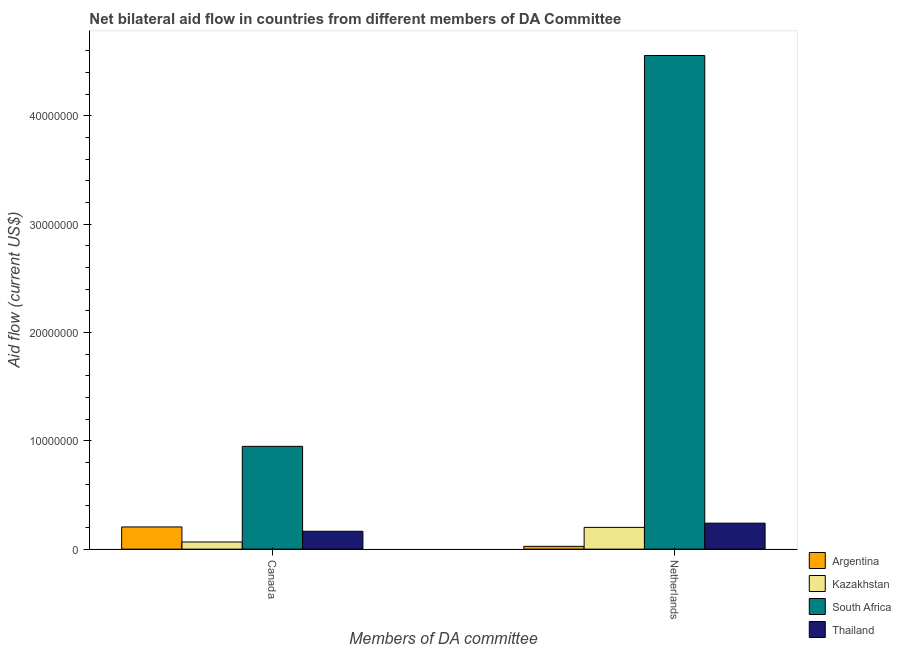How many bars are there on the 2nd tick from the right?
Your answer should be very brief. 4. What is the label of the 2nd group of bars from the left?
Provide a short and direct response. Netherlands. What is the amount of aid given by canada in Argentina?
Keep it short and to the point. 2.05e+06. Across all countries, what is the maximum amount of aid given by canada?
Offer a terse response. 9.49e+06. Across all countries, what is the minimum amount of aid given by canada?
Provide a short and direct response. 6.60e+05. In which country was the amount of aid given by canada maximum?
Offer a terse response. South Africa. In which country was the amount of aid given by netherlands minimum?
Give a very brief answer. Argentina. What is the total amount of aid given by canada in the graph?
Keep it short and to the point. 1.38e+07. What is the difference between the amount of aid given by canada in South Africa and that in Thailand?
Keep it short and to the point. 7.84e+06. What is the difference between the amount of aid given by canada in Thailand and the amount of aid given by netherlands in Argentina?
Keep it short and to the point. 1.39e+06. What is the average amount of aid given by canada per country?
Offer a very short reply. 3.46e+06. What is the difference between the amount of aid given by canada and amount of aid given by netherlands in South Africa?
Your response must be concise. -3.61e+07. What is the ratio of the amount of aid given by netherlands in Argentina to that in Kazakhstan?
Your answer should be very brief. 0.13. Is the amount of aid given by canada in Thailand less than that in Kazakhstan?
Your answer should be compact. No. In how many countries, is the amount of aid given by netherlands greater than the average amount of aid given by netherlands taken over all countries?
Make the answer very short. 1. What does the 4th bar from the left in Canada represents?
Your answer should be very brief. Thailand. What does the 1st bar from the right in Canada represents?
Provide a short and direct response. Thailand. How many bars are there?
Offer a terse response. 8. Are all the bars in the graph horizontal?
Give a very brief answer. No. How many countries are there in the graph?
Your answer should be compact. 4. Does the graph contain grids?
Offer a very short reply. No. What is the title of the graph?
Provide a succinct answer. Net bilateral aid flow in countries from different members of DA Committee. What is the label or title of the X-axis?
Give a very brief answer. Members of DA committee. What is the label or title of the Y-axis?
Keep it short and to the point. Aid flow (current US$). What is the Aid flow (current US$) in Argentina in Canada?
Provide a succinct answer. 2.05e+06. What is the Aid flow (current US$) of South Africa in Canada?
Provide a succinct answer. 9.49e+06. What is the Aid flow (current US$) in Thailand in Canada?
Keep it short and to the point. 1.65e+06. What is the Aid flow (current US$) of Kazakhstan in Netherlands?
Offer a very short reply. 2.01e+06. What is the Aid flow (current US$) of South Africa in Netherlands?
Keep it short and to the point. 4.56e+07. What is the Aid flow (current US$) in Thailand in Netherlands?
Your answer should be compact. 2.40e+06. Across all Members of DA committee, what is the maximum Aid flow (current US$) of Argentina?
Provide a succinct answer. 2.05e+06. Across all Members of DA committee, what is the maximum Aid flow (current US$) of Kazakhstan?
Your answer should be very brief. 2.01e+06. Across all Members of DA committee, what is the maximum Aid flow (current US$) in South Africa?
Your answer should be compact. 4.56e+07. Across all Members of DA committee, what is the maximum Aid flow (current US$) of Thailand?
Provide a succinct answer. 2.40e+06. Across all Members of DA committee, what is the minimum Aid flow (current US$) in Kazakhstan?
Offer a very short reply. 6.60e+05. Across all Members of DA committee, what is the minimum Aid flow (current US$) in South Africa?
Offer a terse response. 9.49e+06. Across all Members of DA committee, what is the minimum Aid flow (current US$) of Thailand?
Give a very brief answer. 1.65e+06. What is the total Aid flow (current US$) of Argentina in the graph?
Ensure brevity in your answer.  2.31e+06. What is the total Aid flow (current US$) in Kazakhstan in the graph?
Give a very brief answer. 2.67e+06. What is the total Aid flow (current US$) of South Africa in the graph?
Give a very brief answer. 5.51e+07. What is the total Aid flow (current US$) in Thailand in the graph?
Ensure brevity in your answer.  4.05e+06. What is the difference between the Aid flow (current US$) in Argentina in Canada and that in Netherlands?
Ensure brevity in your answer.  1.79e+06. What is the difference between the Aid flow (current US$) of Kazakhstan in Canada and that in Netherlands?
Ensure brevity in your answer.  -1.35e+06. What is the difference between the Aid flow (current US$) of South Africa in Canada and that in Netherlands?
Offer a terse response. -3.61e+07. What is the difference between the Aid flow (current US$) of Thailand in Canada and that in Netherlands?
Offer a very short reply. -7.50e+05. What is the difference between the Aid flow (current US$) in Argentina in Canada and the Aid flow (current US$) in South Africa in Netherlands?
Your answer should be very brief. -4.35e+07. What is the difference between the Aid flow (current US$) of Argentina in Canada and the Aid flow (current US$) of Thailand in Netherlands?
Your answer should be compact. -3.50e+05. What is the difference between the Aid flow (current US$) of Kazakhstan in Canada and the Aid flow (current US$) of South Africa in Netherlands?
Offer a terse response. -4.49e+07. What is the difference between the Aid flow (current US$) of Kazakhstan in Canada and the Aid flow (current US$) of Thailand in Netherlands?
Give a very brief answer. -1.74e+06. What is the difference between the Aid flow (current US$) in South Africa in Canada and the Aid flow (current US$) in Thailand in Netherlands?
Offer a very short reply. 7.09e+06. What is the average Aid flow (current US$) in Argentina per Members of DA committee?
Your answer should be compact. 1.16e+06. What is the average Aid flow (current US$) of Kazakhstan per Members of DA committee?
Offer a terse response. 1.34e+06. What is the average Aid flow (current US$) in South Africa per Members of DA committee?
Keep it short and to the point. 2.75e+07. What is the average Aid flow (current US$) of Thailand per Members of DA committee?
Give a very brief answer. 2.02e+06. What is the difference between the Aid flow (current US$) of Argentina and Aid flow (current US$) of Kazakhstan in Canada?
Make the answer very short. 1.39e+06. What is the difference between the Aid flow (current US$) in Argentina and Aid flow (current US$) in South Africa in Canada?
Your answer should be compact. -7.44e+06. What is the difference between the Aid flow (current US$) in Kazakhstan and Aid flow (current US$) in South Africa in Canada?
Ensure brevity in your answer.  -8.83e+06. What is the difference between the Aid flow (current US$) in Kazakhstan and Aid flow (current US$) in Thailand in Canada?
Give a very brief answer. -9.90e+05. What is the difference between the Aid flow (current US$) in South Africa and Aid flow (current US$) in Thailand in Canada?
Your answer should be compact. 7.84e+06. What is the difference between the Aid flow (current US$) of Argentina and Aid flow (current US$) of Kazakhstan in Netherlands?
Offer a terse response. -1.75e+06. What is the difference between the Aid flow (current US$) in Argentina and Aid flow (current US$) in South Africa in Netherlands?
Provide a succinct answer. -4.53e+07. What is the difference between the Aid flow (current US$) in Argentina and Aid flow (current US$) in Thailand in Netherlands?
Give a very brief answer. -2.14e+06. What is the difference between the Aid flow (current US$) of Kazakhstan and Aid flow (current US$) of South Africa in Netherlands?
Provide a succinct answer. -4.36e+07. What is the difference between the Aid flow (current US$) in Kazakhstan and Aid flow (current US$) in Thailand in Netherlands?
Make the answer very short. -3.90e+05. What is the difference between the Aid flow (current US$) of South Africa and Aid flow (current US$) of Thailand in Netherlands?
Your response must be concise. 4.32e+07. What is the ratio of the Aid flow (current US$) of Argentina in Canada to that in Netherlands?
Give a very brief answer. 7.88. What is the ratio of the Aid flow (current US$) of Kazakhstan in Canada to that in Netherlands?
Keep it short and to the point. 0.33. What is the ratio of the Aid flow (current US$) in South Africa in Canada to that in Netherlands?
Make the answer very short. 0.21. What is the ratio of the Aid flow (current US$) in Thailand in Canada to that in Netherlands?
Offer a very short reply. 0.69. What is the difference between the highest and the second highest Aid flow (current US$) of Argentina?
Provide a short and direct response. 1.79e+06. What is the difference between the highest and the second highest Aid flow (current US$) in Kazakhstan?
Make the answer very short. 1.35e+06. What is the difference between the highest and the second highest Aid flow (current US$) in South Africa?
Make the answer very short. 3.61e+07. What is the difference between the highest and the second highest Aid flow (current US$) of Thailand?
Offer a terse response. 7.50e+05. What is the difference between the highest and the lowest Aid flow (current US$) in Argentina?
Ensure brevity in your answer.  1.79e+06. What is the difference between the highest and the lowest Aid flow (current US$) of Kazakhstan?
Your answer should be compact. 1.35e+06. What is the difference between the highest and the lowest Aid flow (current US$) of South Africa?
Your response must be concise. 3.61e+07. What is the difference between the highest and the lowest Aid flow (current US$) of Thailand?
Your answer should be compact. 7.50e+05. 